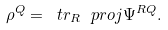Convert formula to latex. <formula><loc_0><loc_0><loc_500><loc_500>\rho ^ { Q } = \ t r _ { R } \ p r o j { \Psi ^ { R Q } } .</formula> 